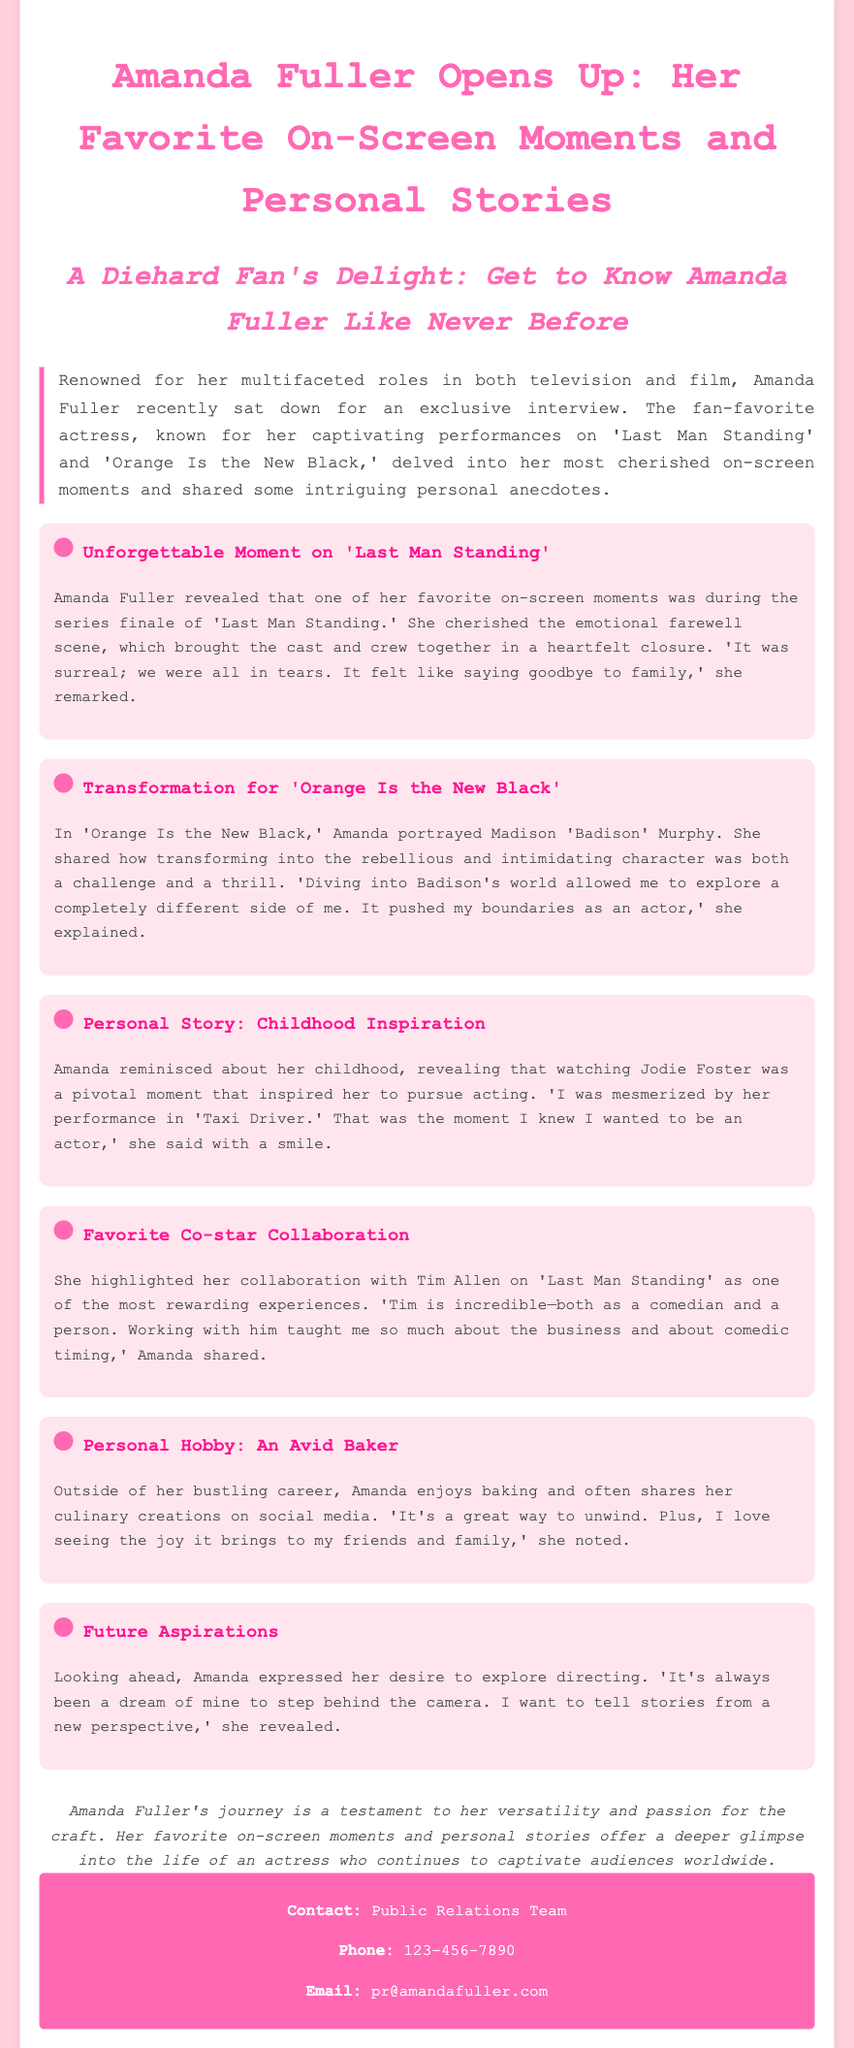What is Amanda Fuller's character in 'Orange Is the New Black'? The document explicitly states that Amanda Fuller portrayed Madison 'Badison' Murphy in 'Orange Is the New Black.'
Answer: Madison 'Badison' Murphy What was Amanda's childhood inspiration? According to the document, Amanda was inspired to pursue acting after watching Jodie Foster, particularly her performance in 'Taxi Driver.'
Answer: Jodie Foster Who did Amanda Fuller collaborate with on 'Last Man Standing'? The document mentions that Amanda highlighted her collaboration with Tim Allen as one of her most rewarding experiences.
Answer: Tim Allen What does Amanda Fuller enjoy doing outside of her acting career? The document states that Amanda enjoys baking and often shares her creations on social media.
Answer: Baking What emotion did Amanda Fuller feel during the series finale of 'Last Man Standing'? The document indicates that Amanda cherished the emotional farewell scene, and she described it as surreal and brought her to tears.
Answer: Tears What does Amanda want to pursue in the future? The document reveals that Amanda expressed a desire to explore directing as a future aspiration.
Answer: Directing What is the main theme of the interview with Amanda Fuller? The document outlines the interview as showcasing Amanda's favorite on-screen moments and personal stories to give fans a deeper glimpse into her life.
Answer: Favorite on-screen moments and personal stories 